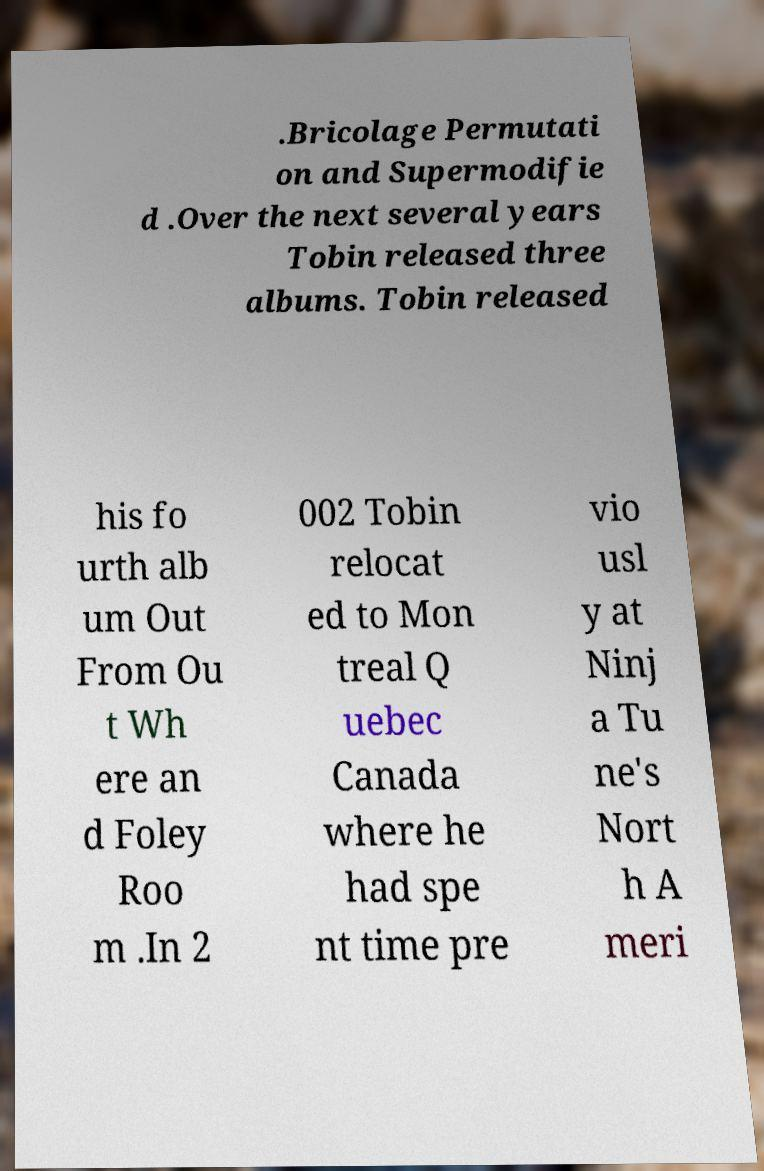For documentation purposes, I need the text within this image transcribed. Could you provide that? .Bricolage Permutati on and Supermodifie d .Over the next several years Tobin released three albums. Tobin released his fo urth alb um Out From Ou t Wh ere an d Foley Roo m .In 2 002 Tobin relocat ed to Mon treal Q uebec Canada where he had spe nt time pre vio usl y at Ninj a Tu ne's Nort h A meri 